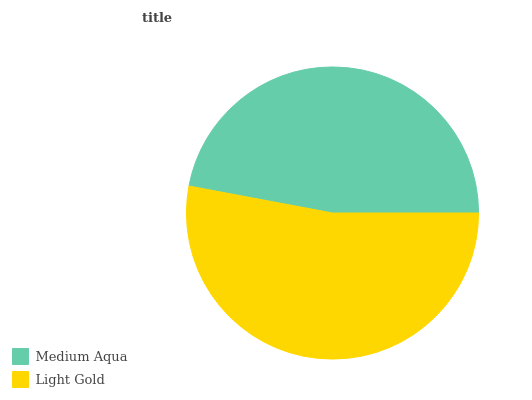Is Medium Aqua the minimum?
Answer yes or no. Yes. Is Light Gold the maximum?
Answer yes or no. Yes. Is Light Gold the minimum?
Answer yes or no. No. Is Light Gold greater than Medium Aqua?
Answer yes or no. Yes. Is Medium Aqua less than Light Gold?
Answer yes or no. Yes. Is Medium Aqua greater than Light Gold?
Answer yes or no. No. Is Light Gold less than Medium Aqua?
Answer yes or no. No. Is Light Gold the high median?
Answer yes or no. Yes. Is Medium Aqua the low median?
Answer yes or no. Yes. Is Medium Aqua the high median?
Answer yes or no. No. Is Light Gold the low median?
Answer yes or no. No. 